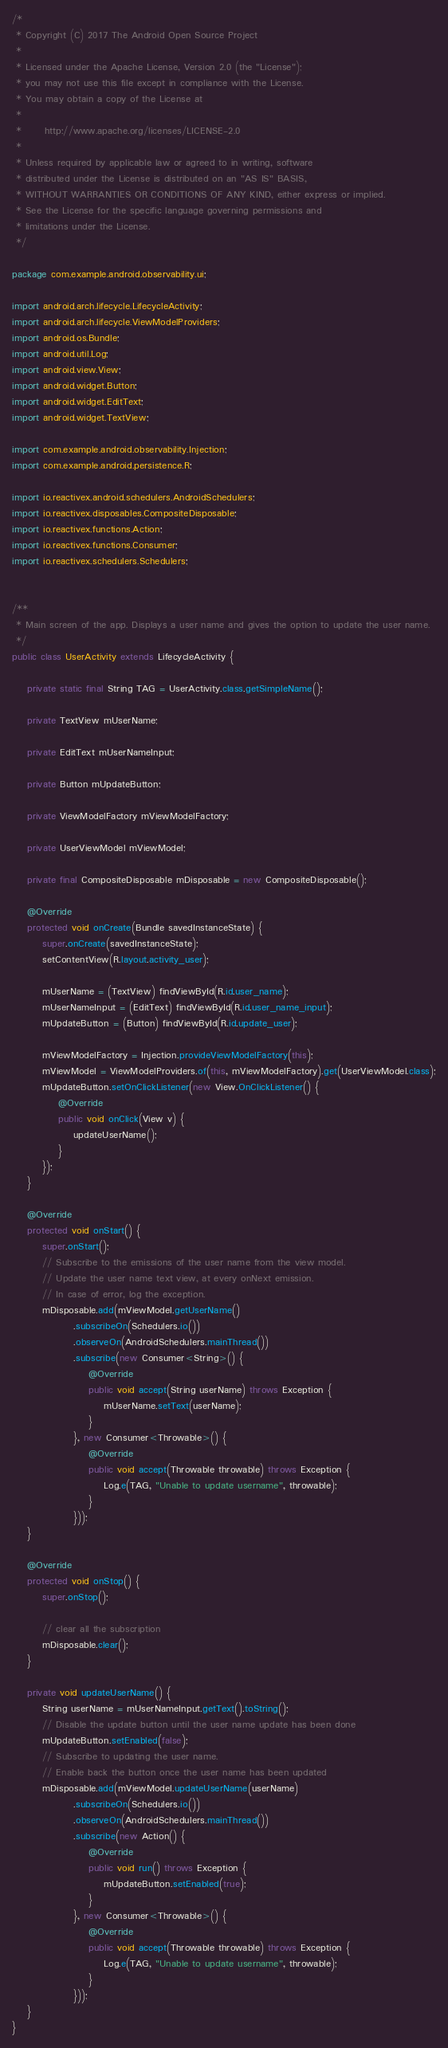<code> <loc_0><loc_0><loc_500><loc_500><_Java_>/*
 * Copyright (C) 2017 The Android Open Source Project
 *
 * Licensed under the Apache License, Version 2.0 (the "License");
 * you may not use this file except in compliance with the License.
 * You may obtain a copy of the License at
 *
 *      http://www.apache.org/licenses/LICENSE-2.0
 *
 * Unless required by applicable law or agreed to in writing, software
 * distributed under the License is distributed on an "AS IS" BASIS,
 * WITHOUT WARRANTIES OR CONDITIONS OF ANY KIND, either express or implied.
 * See the License for the specific language governing permissions and
 * limitations under the License.
 */

package com.example.android.observability.ui;

import android.arch.lifecycle.LifecycleActivity;
import android.arch.lifecycle.ViewModelProviders;
import android.os.Bundle;
import android.util.Log;
import android.view.View;
import android.widget.Button;
import android.widget.EditText;
import android.widget.TextView;

import com.example.android.observability.Injection;
import com.example.android.persistence.R;

import io.reactivex.android.schedulers.AndroidSchedulers;
import io.reactivex.disposables.CompositeDisposable;
import io.reactivex.functions.Action;
import io.reactivex.functions.Consumer;
import io.reactivex.schedulers.Schedulers;


/**
 * Main screen of the app. Displays a user name and gives the option to update the user name.
 */
public class UserActivity extends LifecycleActivity {

    private static final String TAG = UserActivity.class.getSimpleName();

    private TextView mUserName;

    private EditText mUserNameInput;

    private Button mUpdateButton;

    private ViewModelFactory mViewModelFactory;

    private UserViewModel mViewModel;

    private final CompositeDisposable mDisposable = new CompositeDisposable();

    @Override
    protected void onCreate(Bundle savedInstanceState) {
        super.onCreate(savedInstanceState);
        setContentView(R.layout.activity_user);

        mUserName = (TextView) findViewById(R.id.user_name);
        mUserNameInput = (EditText) findViewById(R.id.user_name_input);
        mUpdateButton = (Button) findViewById(R.id.update_user);

        mViewModelFactory = Injection.provideViewModelFactory(this);
        mViewModel = ViewModelProviders.of(this, mViewModelFactory).get(UserViewModel.class);
        mUpdateButton.setOnClickListener(new View.OnClickListener() {
            @Override
            public void onClick(View v) {
                updateUserName();
            }
        });
    }

    @Override
    protected void onStart() {
        super.onStart();
        // Subscribe to the emissions of the user name from the view model.
        // Update the user name text view, at every onNext emission.
        // In case of error, log the exception.
        mDisposable.add(mViewModel.getUserName()
                .subscribeOn(Schedulers.io())
                .observeOn(AndroidSchedulers.mainThread())
                .subscribe(new Consumer<String>() {
                    @Override
                    public void accept(String userName) throws Exception {
                        mUserName.setText(userName);
                    }
                }, new Consumer<Throwable>() {
                    @Override
                    public void accept(Throwable throwable) throws Exception {
                        Log.e(TAG, "Unable to update username", throwable);
                    }
                }));
    }

    @Override
    protected void onStop() {
        super.onStop();

        // clear all the subscription
        mDisposable.clear();
    }

    private void updateUserName() {
        String userName = mUserNameInput.getText().toString();
        // Disable the update button until the user name update has been done
        mUpdateButton.setEnabled(false);
        // Subscribe to updating the user name.
        // Enable back the button once the user name has been updated
        mDisposable.add(mViewModel.updateUserName(userName)
                .subscribeOn(Schedulers.io())
                .observeOn(AndroidSchedulers.mainThread())
                .subscribe(new Action() {
                    @Override
                    public void run() throws Exception {
                        mUpdateButton.setEnabled(true);
                    }
                }, new Consumer<Throwable>() {
                    @Override
                    public void accept(Throwable throwable) throws Exception {
                        Log.e(TAG, "Unable to update username", throwable);
                    }
                }));
    }
}
</code> 